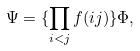<formula> <loc_0><loc_0><loc_500><loc_500>\Psi = \{ \prod _ { i < j } f ( i j ) \} \Phi ,</formula> 